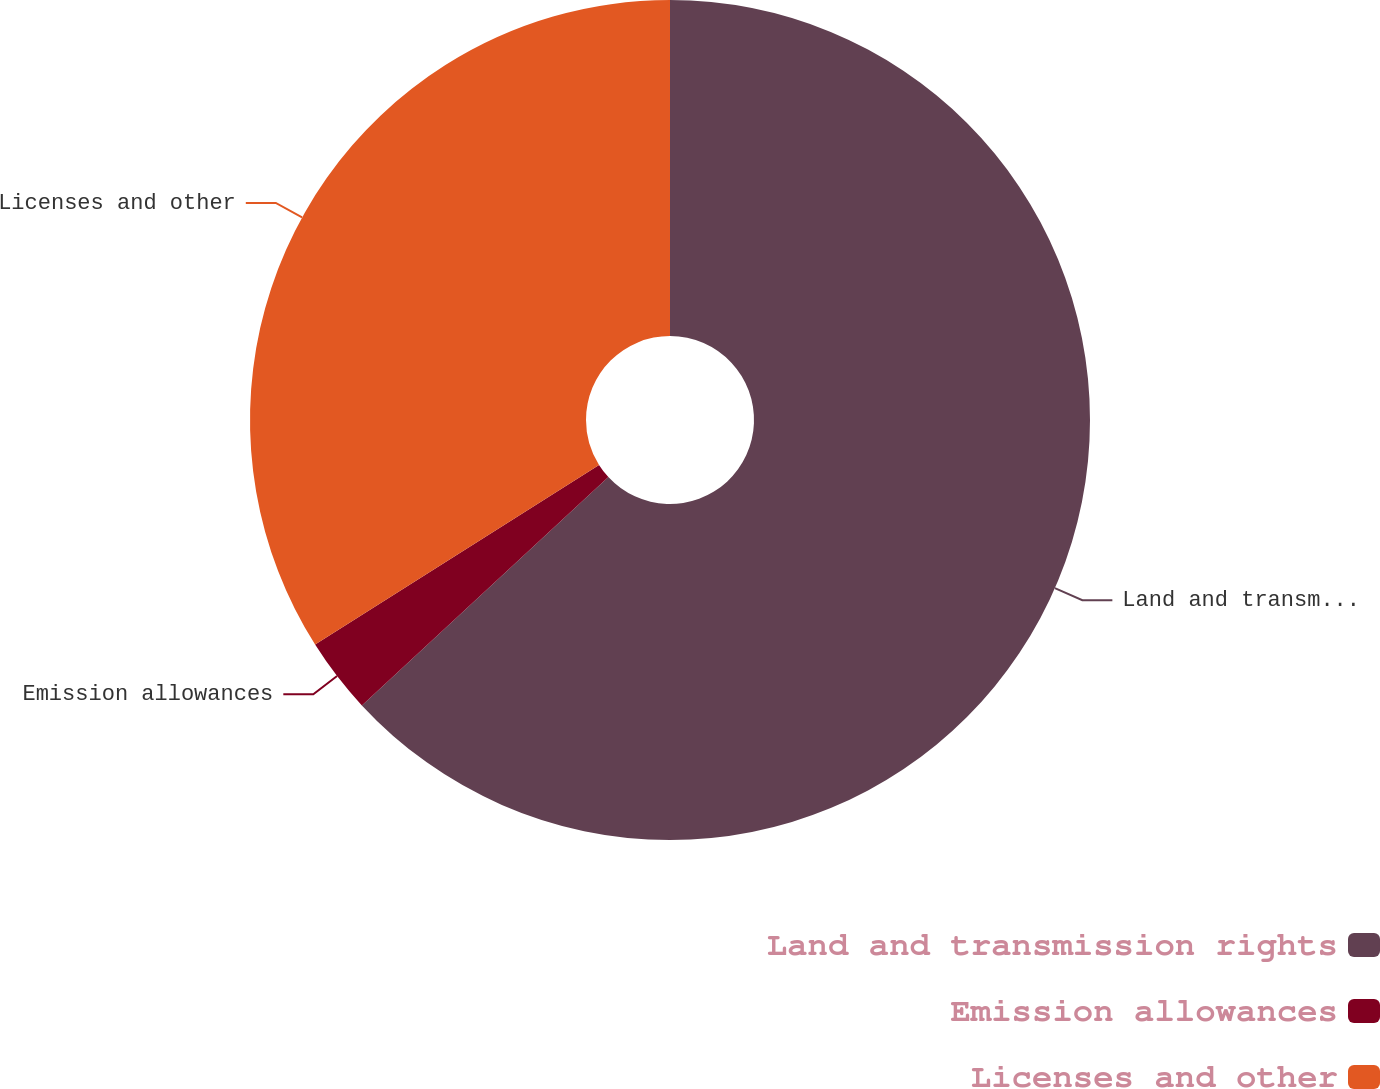<chart> <loc_0><loc_0><loc_500><loc_500><pie_chart><fcel>Land and transmission rights<fcel>Emission allowances<fcel>Licenses and other<nl><fcel>63.11%<fcel>2.91%<fcel>33.98%<nl></chart> 